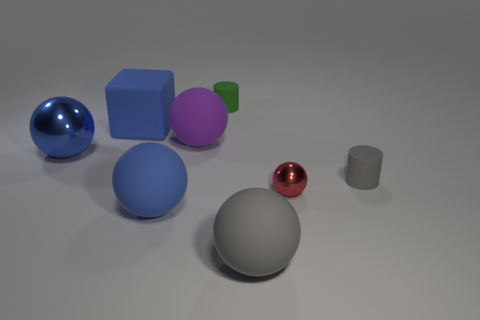Subtract all green cylinders. How many blue balls are left? 2 Subtract all gray spheres. How many spheres are left? 4 Subtract all red spheres. How many spheres are left? 4 Add 1 red rubber cubes. How many objects exist? 9 Subtract all green spheres. Subtract all blue cylinders. How many spheres are left? 5 Subtract all balls. How many objects are left? 3 Subtract all big blocks. Subtract all small balls. How many objects are left? 6 Add 7 large blue matte spheres. How many large blue matte spheres are left? 8 Add 8 large gray cubes. How many large gray cubes exist? 8 Subtract 1 purple balls. How many objects are left? 7 